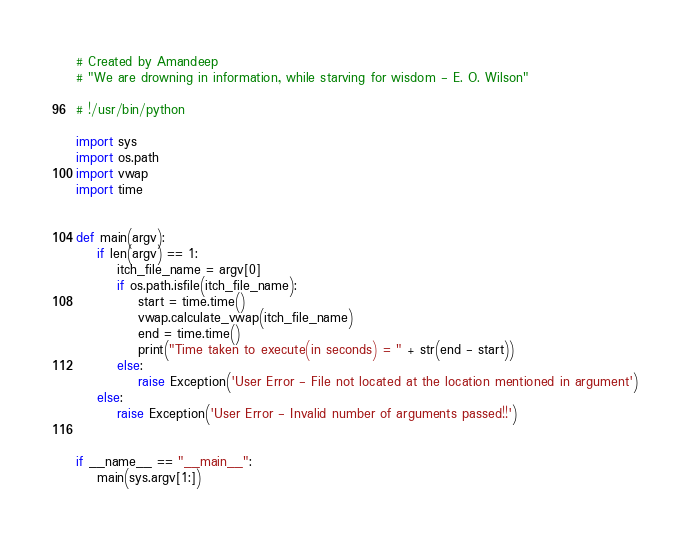<code> <loc_0><loc_0><loc_500><loc_500><_Python_># Created by Amandeep
# "We are drowning in information, while starving for wisdom - E. O. Wilson"

# !/usr/bin/python

import sys
import os.path
import vwap
import time


def main(argv):
    if len(argv) == 1:
        itch_file_name = argv[0]
        if os.path.isfile(itch_file_name):
            start = time.time()
            vwap.calculate_vwap(itch_file_name)
            end = time.time()
            print("Time taken to execute(in seconds) = " + str(end - start))
        else:
            raise Exception('User Error - File not located at the location mentioned in argument')
    else:
        raise Exception('User Error - Invalid number of arguments passed!!')


if __name__ == "__main__":
    main(sys.argv[1:])</code> 